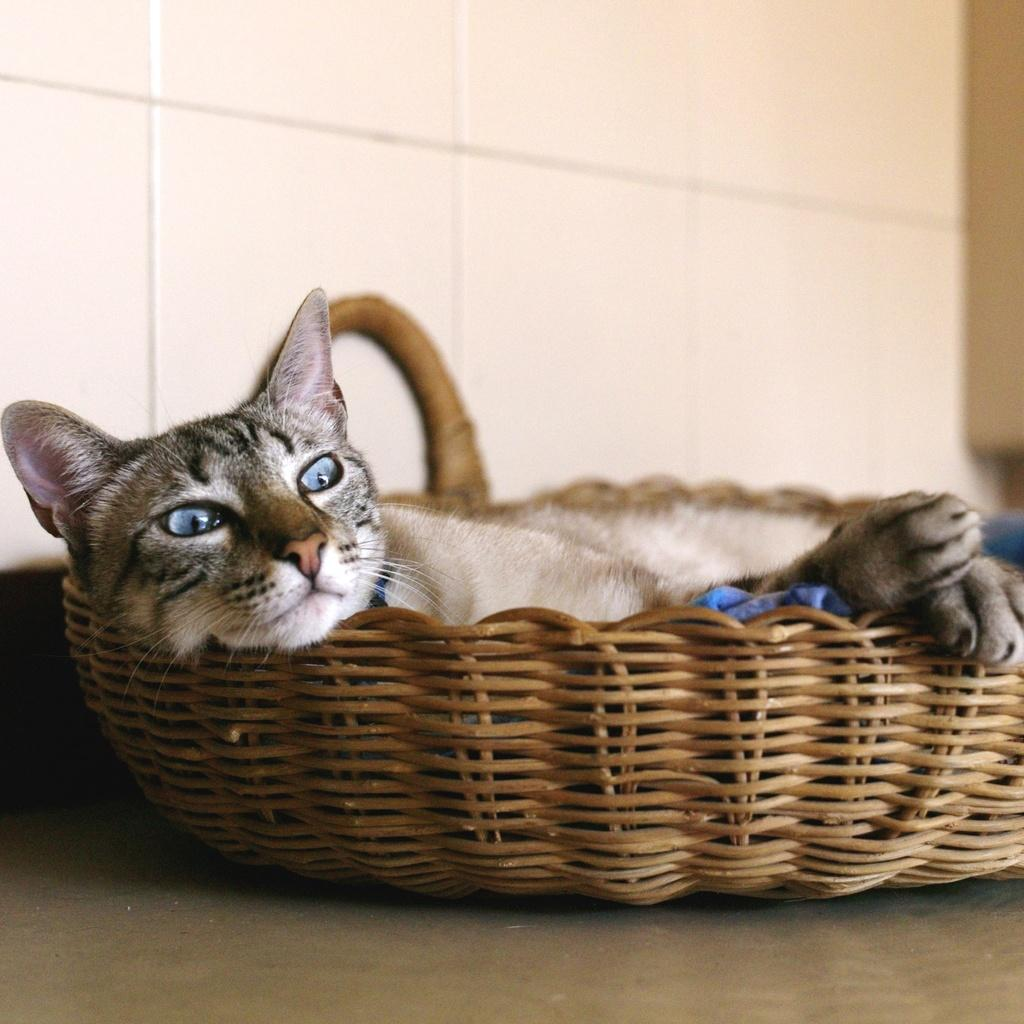What animal is present in the image? There is a cat in the image. Where is the cat located? The cat is in a basket. What can be seen in the background of the image? There is a wall in the background of the image. What type of butter is being used to conduct a science experiment in the image? There is no butter or science experiment present in the image; it features a cat in a basket with a wall in the background. 